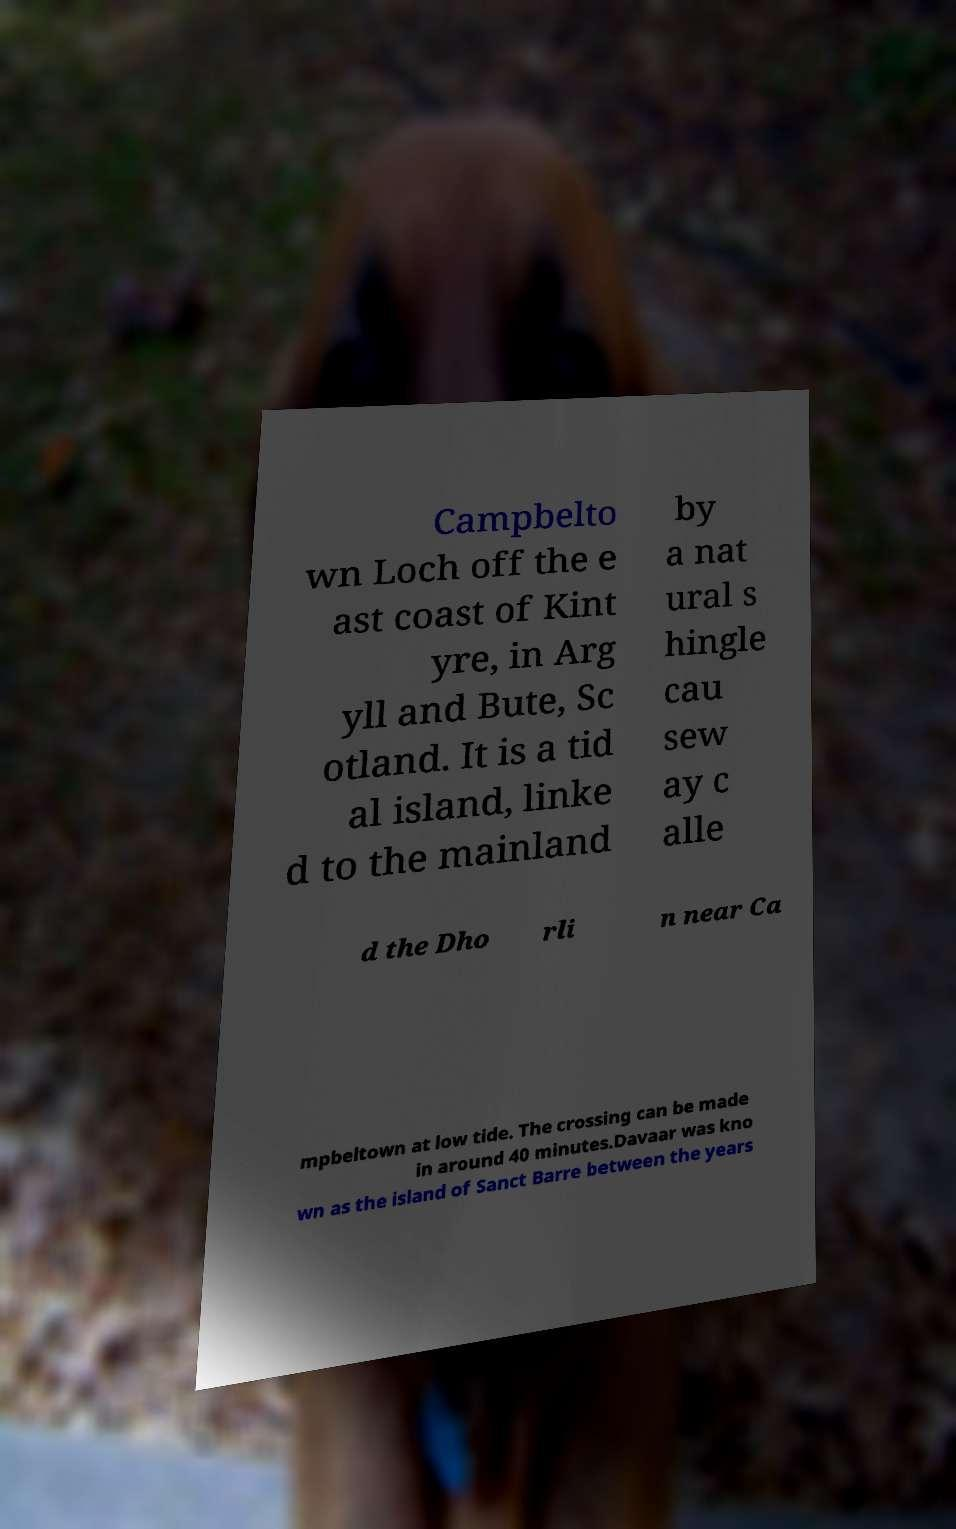For documentation purposes, I need the text within this image transcribed. Could you provide that? Campbelto wn Loch off the e ast coast of Kint yre, in Arg yll and Bute, Sc otland. It is a tid al island, linke d to the mainland by a nat ural s hingle cau sew ay c alle d the Dho rli n near Ca mpbeltown at low tide. The crossing can be made in around 40 minutes.Davaar was kno wn as the island of Sanct Barre between the years 